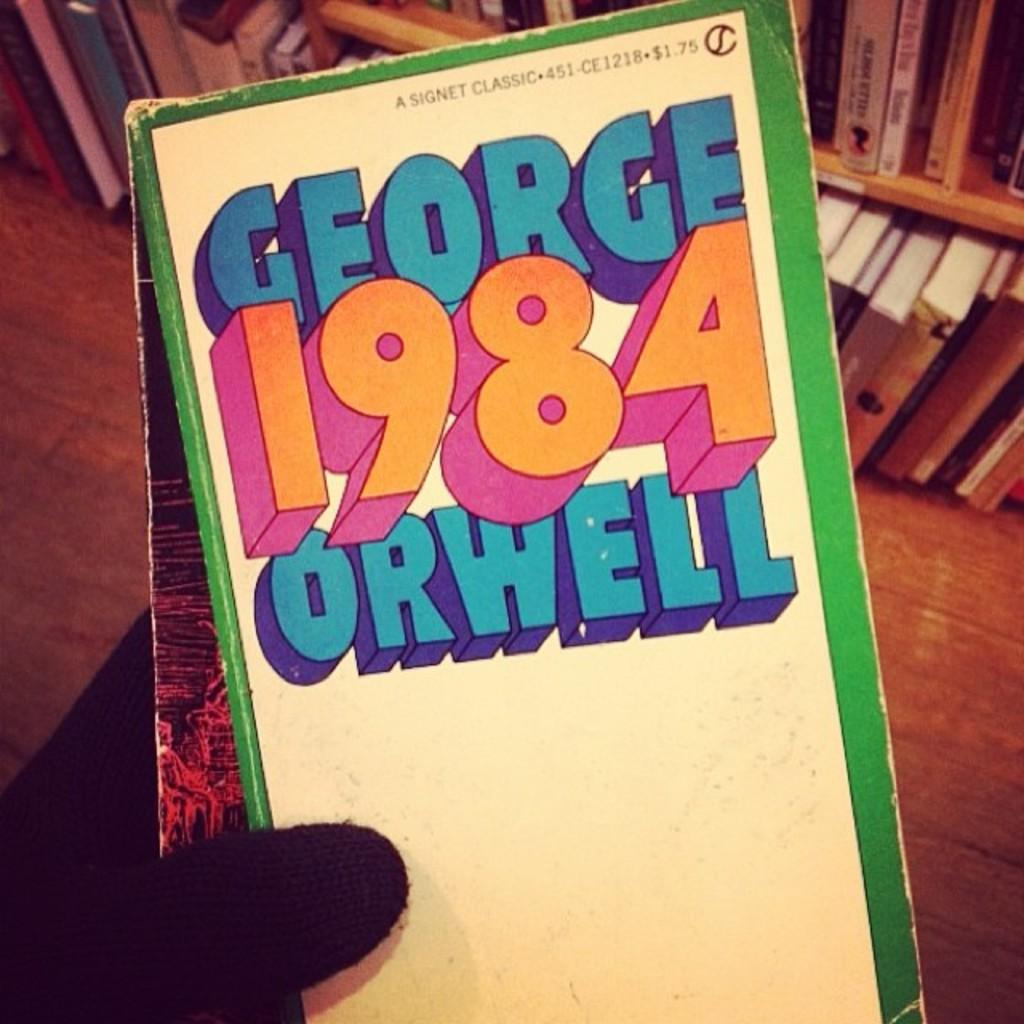<image>
Create a compact narrative representing the image presented. A person is holding a book that says George 1984 Orwell. 